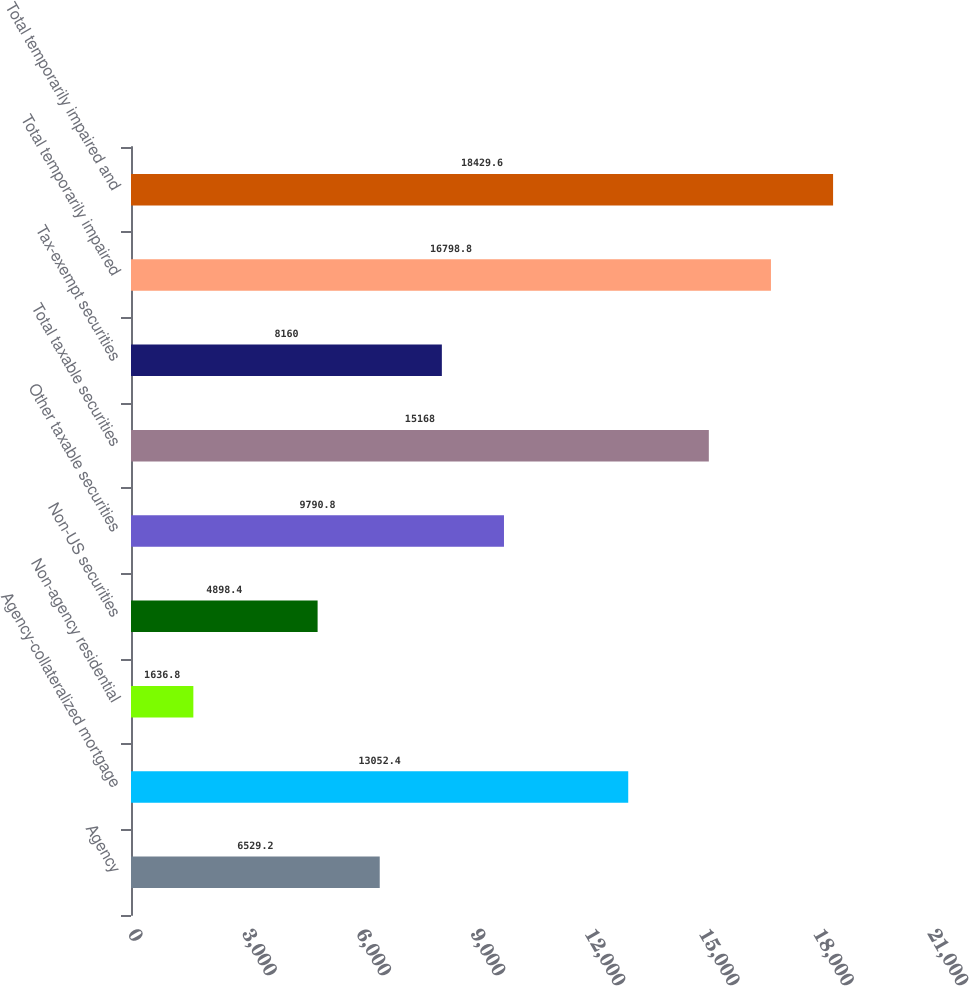Convert chart. <chart><loc_0><loc_0><loc_500><loc_500><bar_chart><fcel>Agency<fcel>Agency-collateralized mortgage<fcel>Non-agency residential<fcel>Non-US securities<fcel>Other taxable securities<fcel>Total taxable securities<fcel>Tax-exempt securities<fcel>Total temporarily impaired<fcel>Total temporarily impaired and<nl><fcel>6529.2<fcel>13052.4<fcel>1636.8<fcel>4898.4<fcel>9790.8<fcel>15168<fcel>8160<fcel>16798.8<fcel>18429.6<nl></chart> 